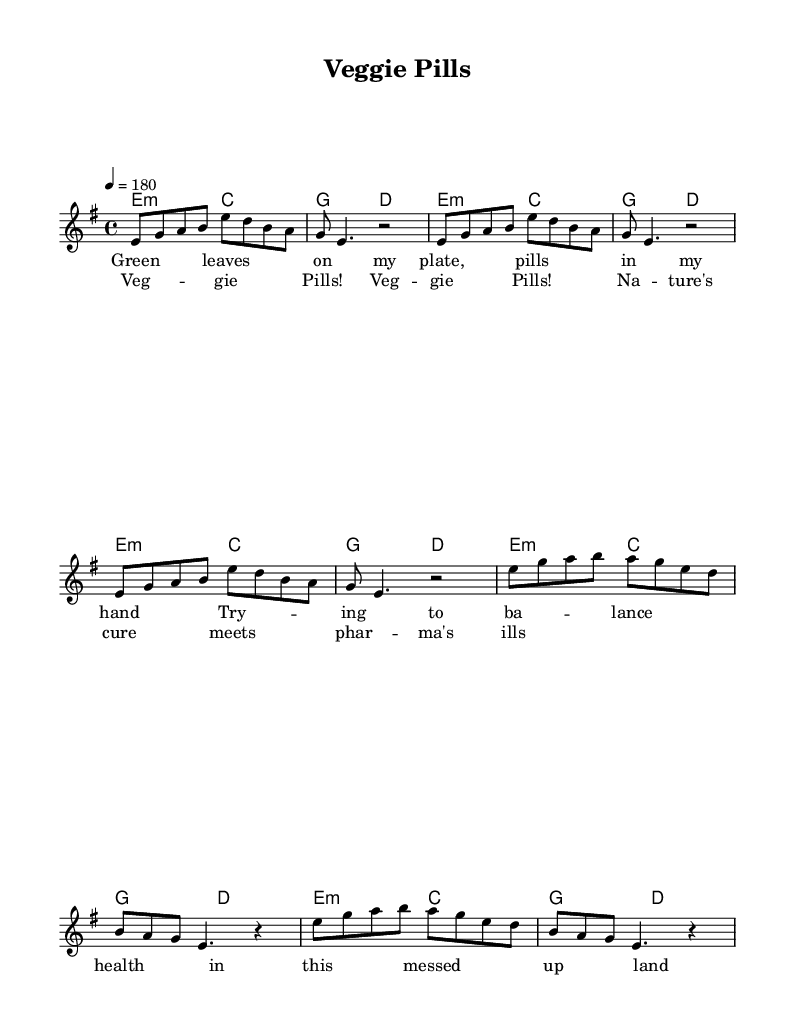What is the key signature of this music? The key signature is E minor, which has one sharp (F#). This can be identified at the beginning of the staff where the key signatures are placed.
Answer: E minor What is the time signature of this music? The time signature is 4/4, indicated at the beginning of the score. This means there are four beats in each measure, with a quarter note receiving one beat.
Answer: 4/4 What is the tempo indicated in the music? The tempo is marked as 180 beats per minute, as shown at the top of the score. This indicates how fast the piece should be played.
Answer: 180 How many sections are there in the song? The song consists of three main sections: the Intro, Verse, and Chorus, as indicated by the structure of the melody and lyrics.
Answer: Three What are the last two lines of the chorus? The last two lines of the chorus are: "Na - ture's cure meets phar - ma's ills" as seen in the lyric portion of the sheet music under the corresponding melody line.
Answer: Na - ture's cure meets phar - ma's ills How many measures does the verse span? The verse spans 8 measures, which can be counted from the notation provided in the score, including repetitions.
Answer: 8 What is the predominant chord used throughout the song? The predominant chord used throughout the song is E minor, as indicated in the chord progression laid out in the harmonies section.
Answer: E minor 